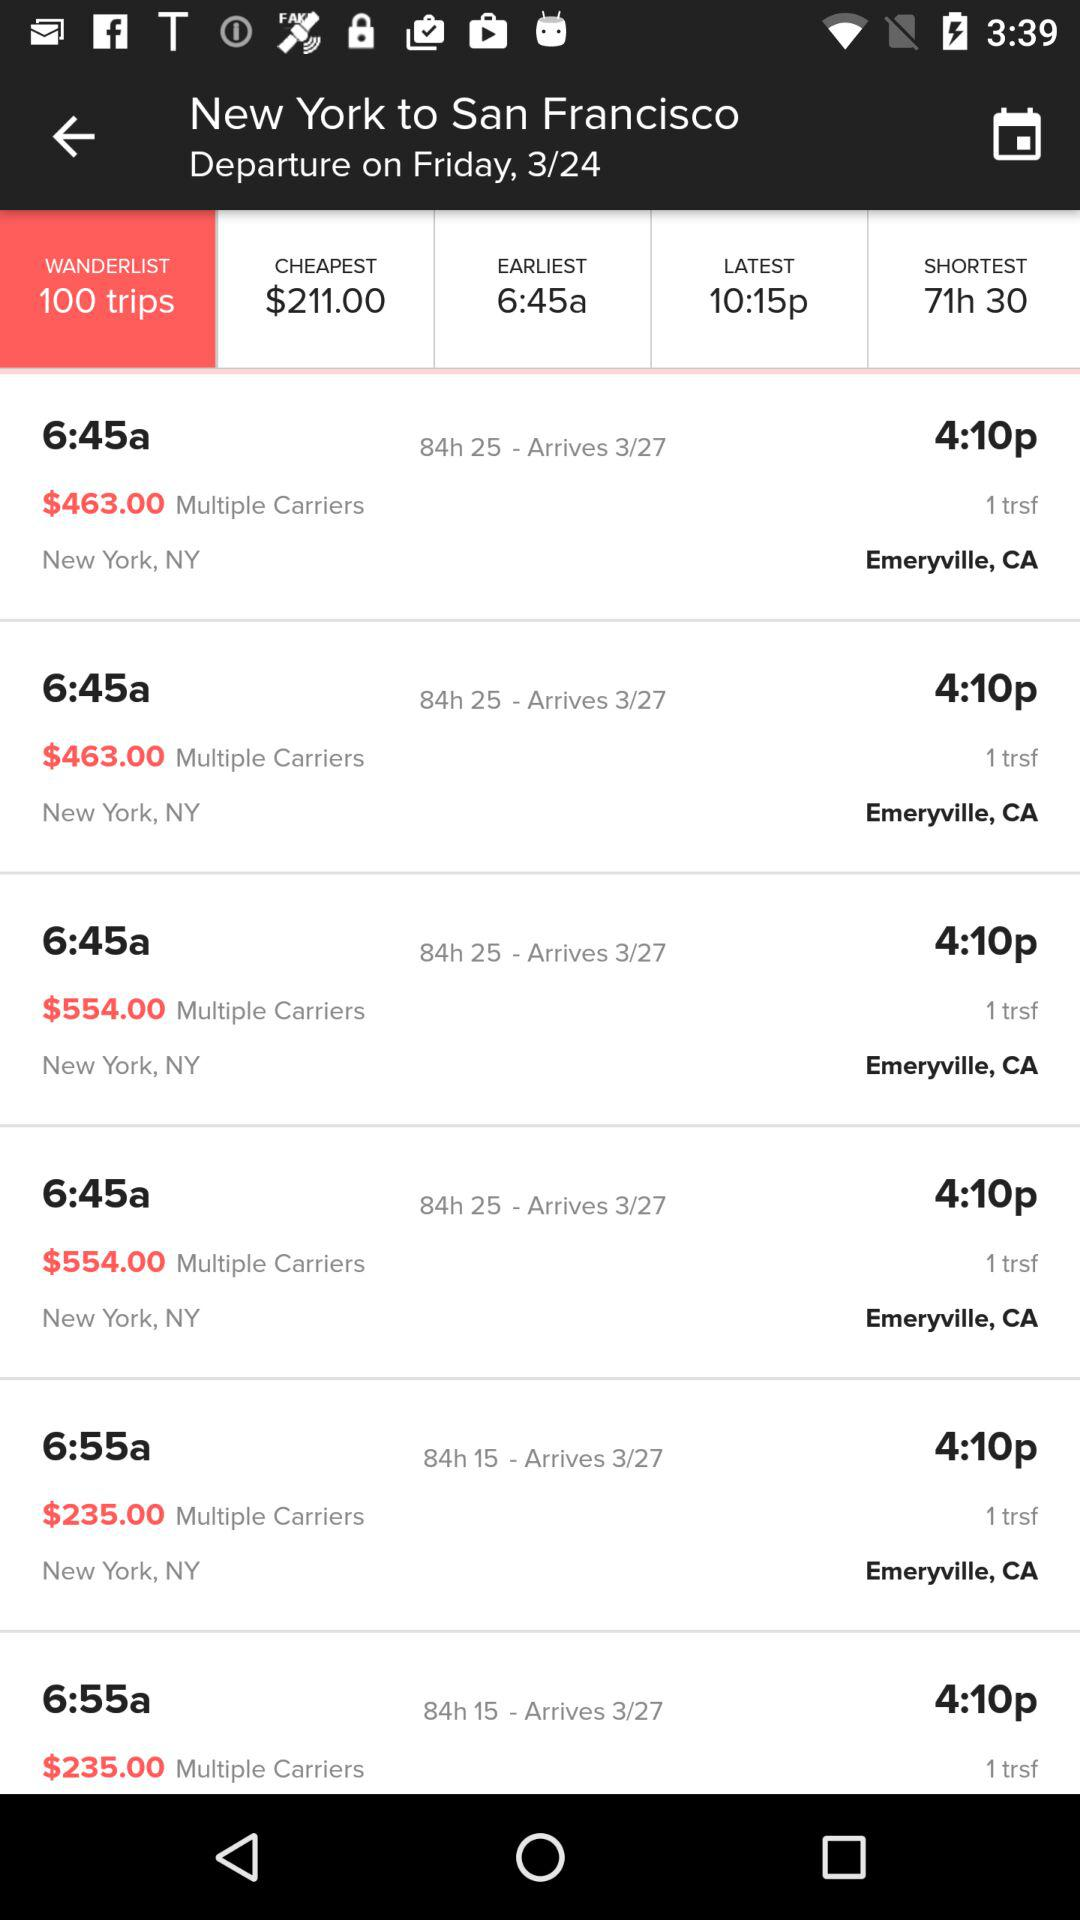What is the cheapest price? The cheapest price is $211.00. 